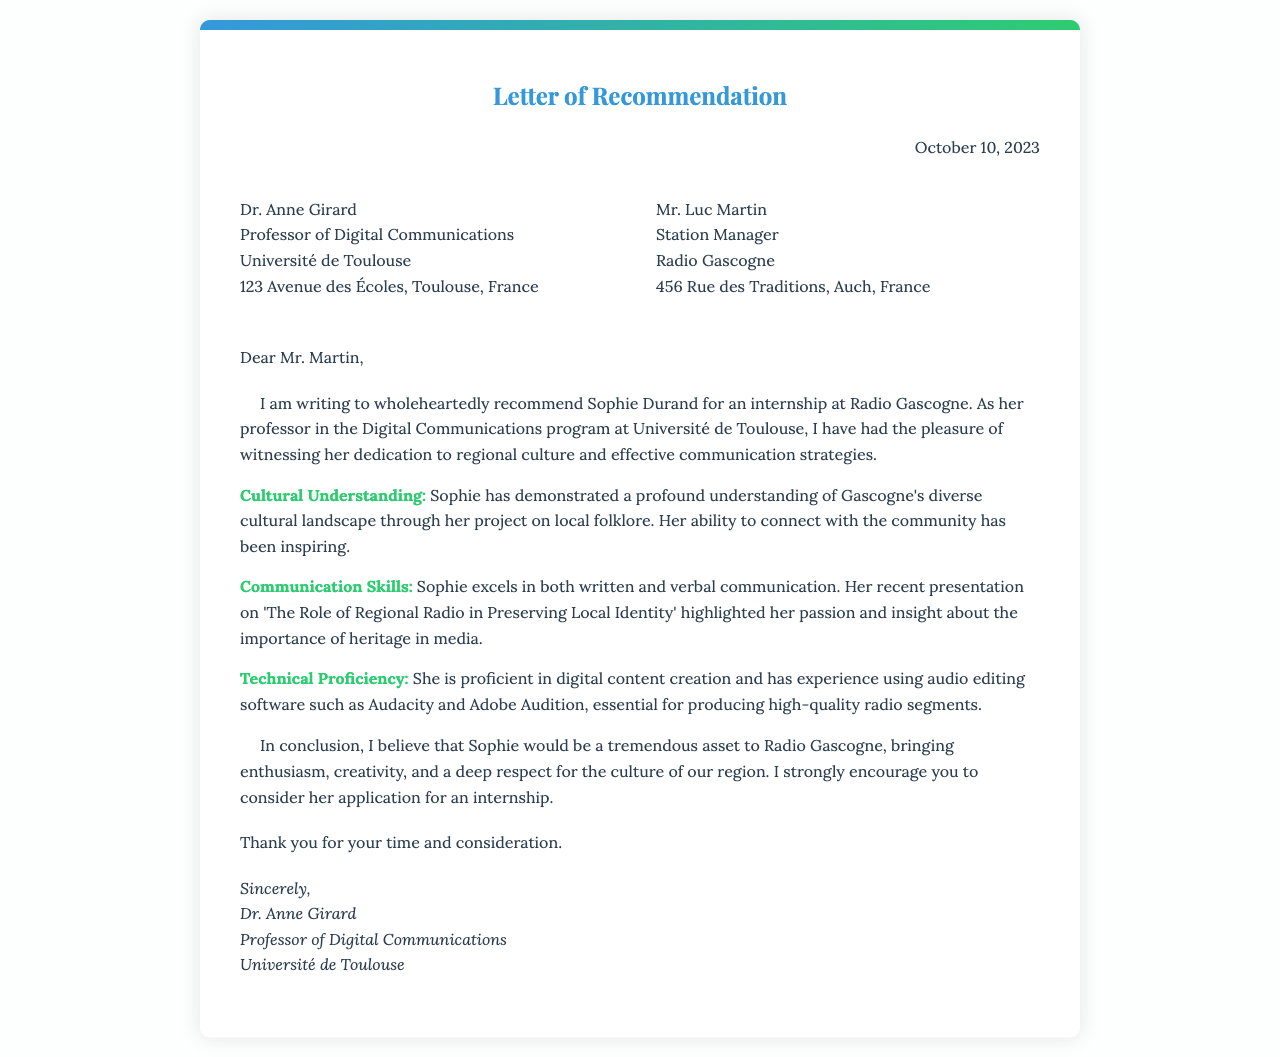What is the date of the letter? The date of the letter is mentioned in the document's opening section.
Answer: October 10, 2023 Who is the sender of the letter? The sender is identified at the top of the document as Dr. Anne Girard.
Answer: Dr. Anne Girard What is the recipient's position? The letter indicates the title of the person to whom it is addressed, which is found in the recipient's section.
Answer: Station Manager What cultural project did Sophie complete? This detail is provided under the Cultural Understanding section in the body of the letter.
Answer: Local folklore What software is mentioned in relation to Sophie's technical skills? The software used by Sophie for her digital content creation is specifically noted in the Technical Proficiency section.
Answer: Audacity and Adobe Audition What is the main theme of Sophie’s recent presentation? The main theme can be found in the Communication Skills section of the letter.
Answer: The Role of Regional Radio in Preserving Local Identity Who is recommending Sophie for the internship? The author of the letter explicitly states their name and position at the beginning.
Answer: Dr. Anne Girard What quality is emphasized about Sophie’s communication skills? The letter discusses a particular aspect of her communication abilities in a specific section.
Answer: Both written and verbal communication How does Dr. Girard describe Sophie’s potential contribution to Radio Gascogne? The closing paragraph summarizes Dr. Girard's view on what Sophie would bring to the station.
Answer: Tremendous asset 